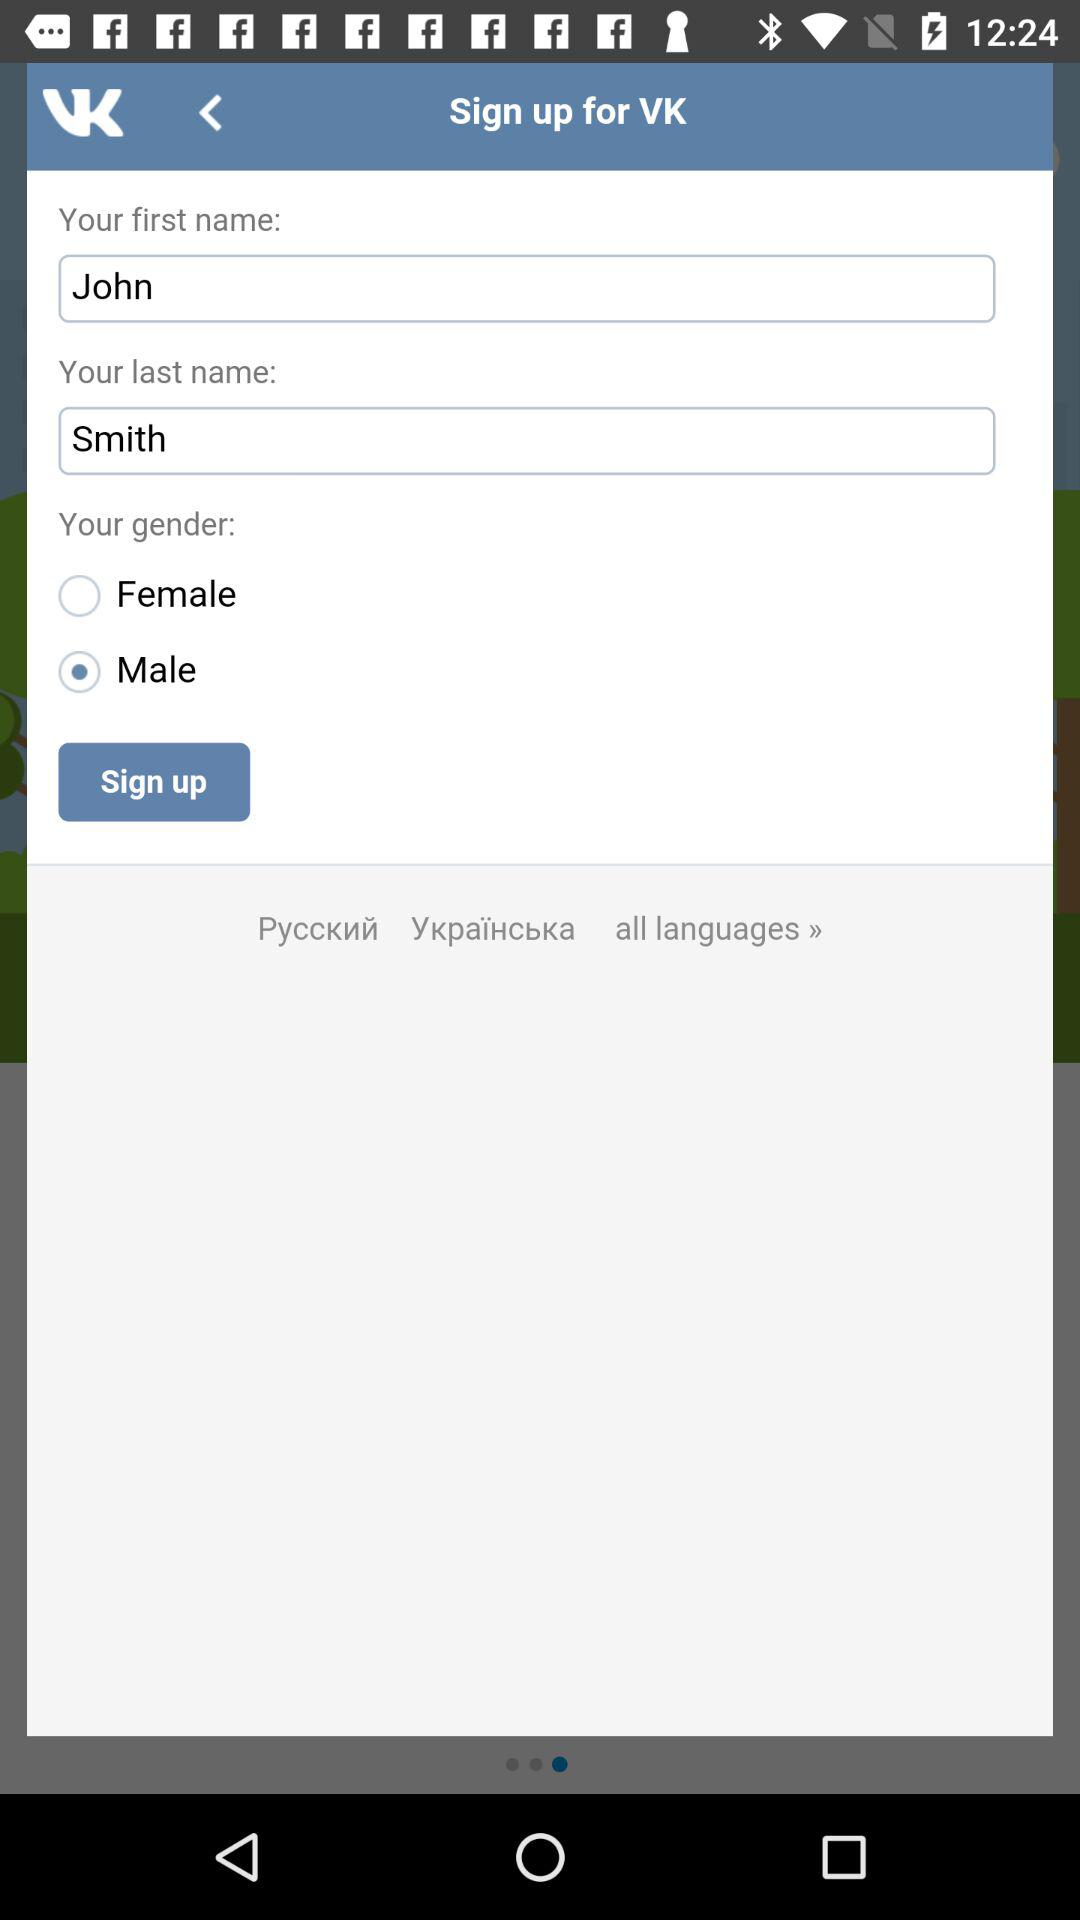Which gender is selected? The selected gender is male. 